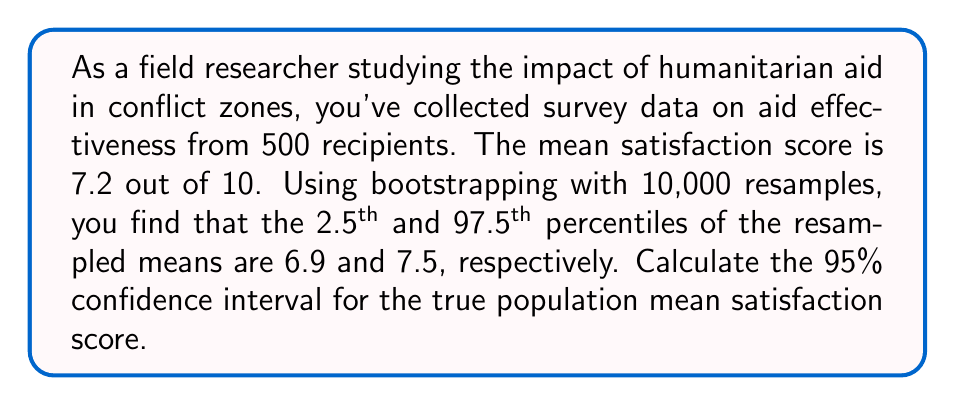Solve this math problem. 1) In this scenario, we're using bootstrapping to estimate the confidence interval for the population mean satisfaction score. The bootstrap method involves:
   a) Resampling with replacement from the original sample
   b) Calculating the statistic of interest (mean) for each resample
   c) Repeating this process many times (in this case, 10,000 times)
   d) Using the distribution of these resampled statistics to estimate the confidence interval

2) The 2.5th and 97.5th percentiles of the resampled means represent the lower and upper bounds of the 95% confidence interval, respectively.

3) Given:
   - 2.5th percentile of resampled means = 6.9
   - 97.5th percentile of resampled means = 7.5

4) The 95% confidence interval is therefore:

   $$CI_{95\%} = [6.9, 7.5]$$

5) Interpretation: We can be 95% confident that the true population mean satisfaction score falls between 6.9 and 7.5.

6) The width of this interval (7.5 - 6.9 = 0.6) gives us an idea of the precision of our estimate. A narrower interval would indicate a more precise estimate.

7) It's important to note that this method doesn't rely on the assumption of normality, which is particularly useful when dealing with potentially non-normal distributions in field research.
Answer: $[6.9, 7.5]$ 